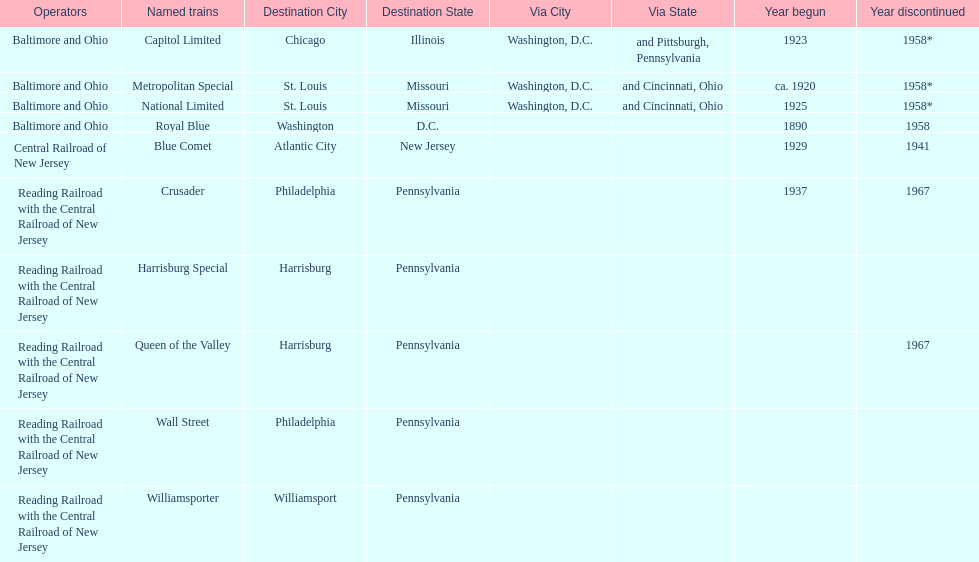What is the total of named trains? 10. 